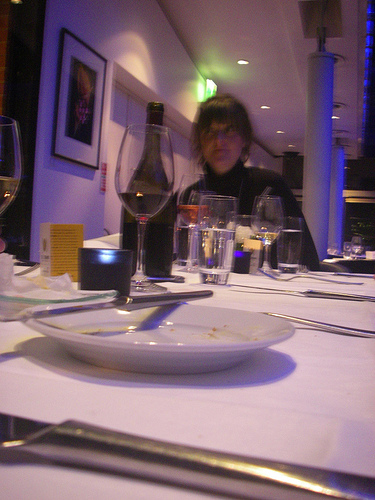<image>
Can you confirm if the glass is in the plate? No. The glass is not contained within the plate. These objects have a different spatial relationship. Where is the bottle in relation to the wine glass? Is it next to the wine glass? Yes. The bottle is positioned adjacent to the wine glass, located nearby in the same general area. 